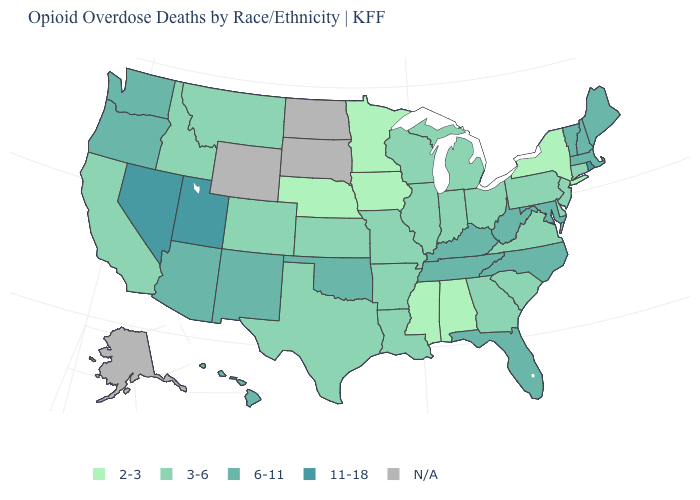Does the map have missing data?
Give a very brief answer. Yes. Which states hav the highest value in the West?
Write a very short answer. Nevada, Utah. Among the states that border Ohio , does Indiana have the lowest value?
Give a very brief answer. Yes. What is the highest value in the USA?
Write a very short answer. 11-18. What is the value of Wisconsin?
Write a very short answer. 3-6. Does the map have missing data?
Short answer required. Yes. Does Rhode Island have the highest value in the USA?
Short answer required. Yes. What is the value of Alabama?
Concise answer only. 2-3. Among the states that border Illinois , which have the lowest value?
Write a very short answer. Iowa. Which states have the lowest value in the South?
Give a very brief answer. Alabama, Mississippi. Name the states that have a value in the range N/A?
Short answer required. Alaska, North Dakota, South Dakota, Wyoming. What is the value of Kentucky?
Give a very brief answer. 6-11. Name the states that have a value in the range N/A?
Quick response, please. Alaska, North Dakota, South Dakota, Wyoming. What is the highest value in the USA?
Short answer required. 11-18. Does Mississippi have the lowest value in the USA?
Write a very short answer. Yes. 